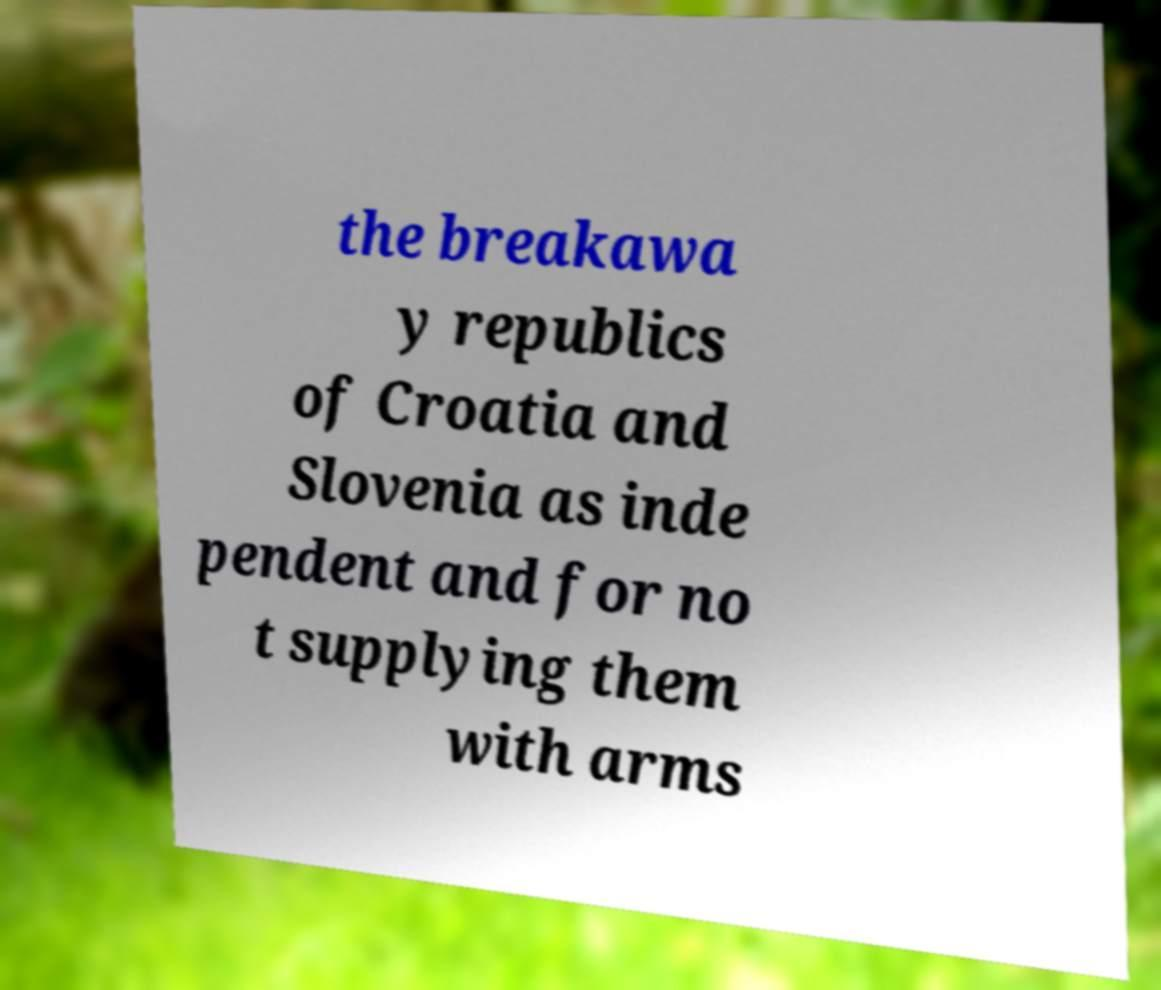I need the written content from this picture converted into text. Can you do that? the breakawa y republics of Croatia and Slovenia as inde pendent and for no t supplying them with arms 